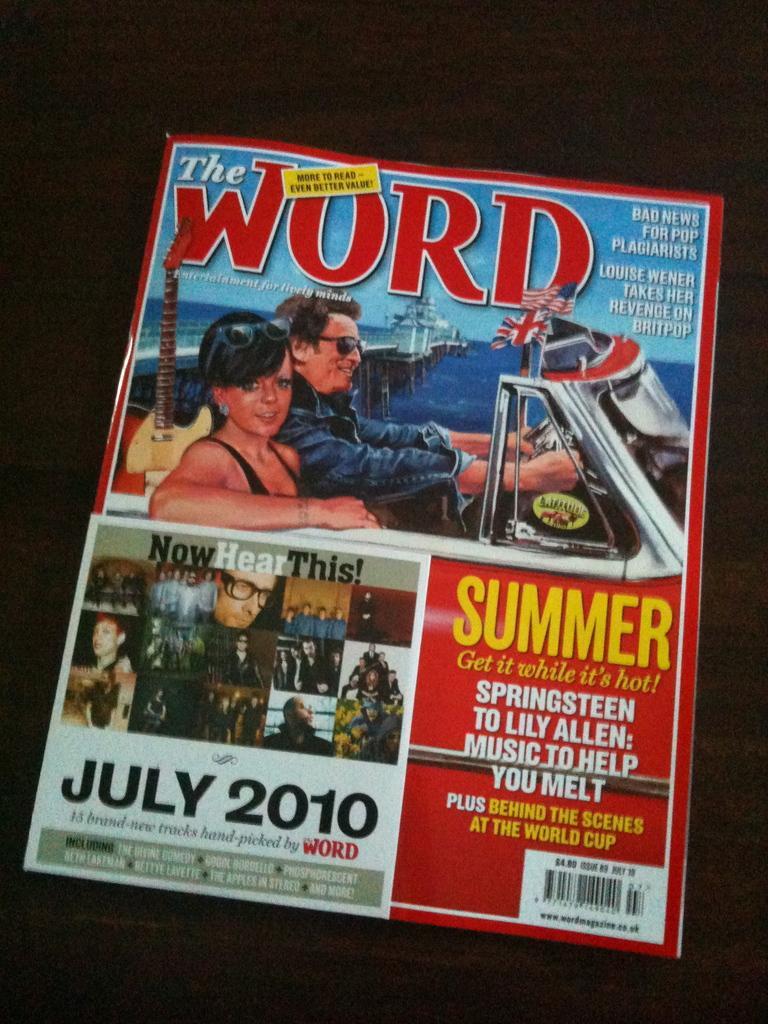Could you give a brief overview of what you see in this image? In the image there is a magazine with two persons going in the car above and below there is a photo grid image of various persons on it. 